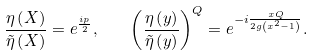<formula> <loc_0><loc_0><loc_500><loc_500>\frac { \eta \left ( X \right ) } { \tilde { \eta } \left ( X \right ) } = e ^ { \frac { i p } { 2 } } , \quad \left ( \frac { \eta \left ( y \right ) } { \tilde { \eta } \left ( y \right ) } \right ) ^ { Q } = e ^ { - i \frac { x Q } { 2 g \left ( x ^ { 2 } - 1 \right ) } } .</formula> 